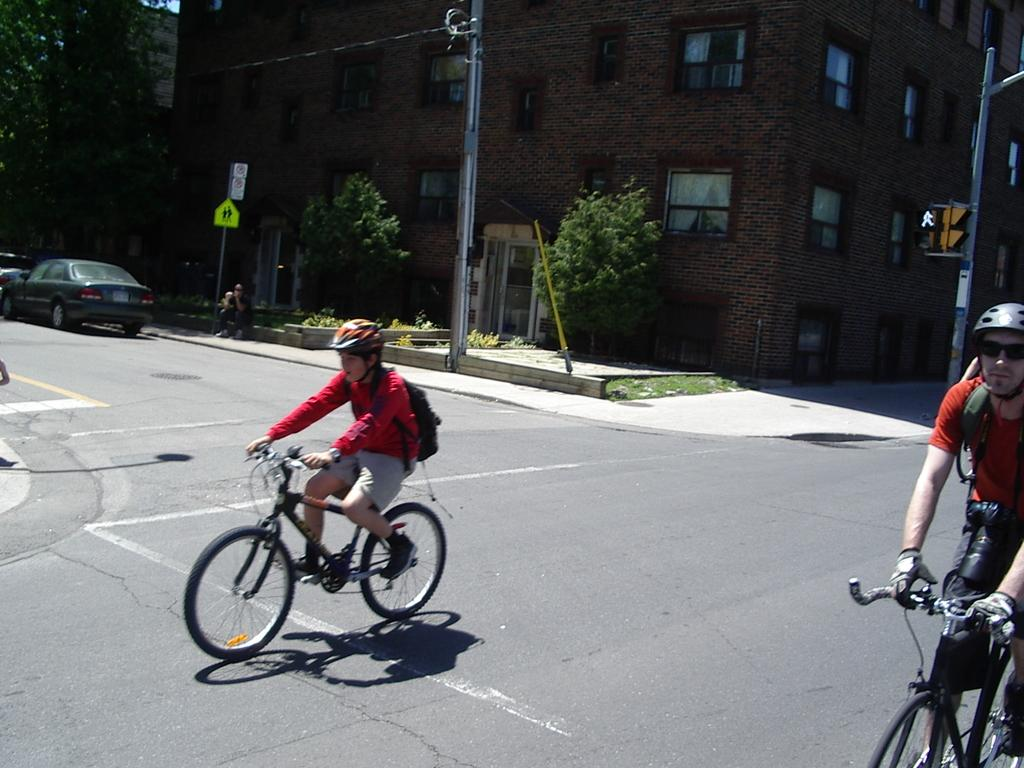How many people are riding the bicycle in the image? There are two people riding the bicycle in the image. Where is the bicycle located? The bicycle is on the road in the image. What can be seen on the left side of the road? There are cars parked on the left side of the road in the image. What is present on the right side of the road? There is a signal on the right side of the road in the image. Can you see any sea creatures swimming near the bicycle in the image? There is no sea or sea creatures present in the image; it features a bicycle on a road with parked cars and a signal. 